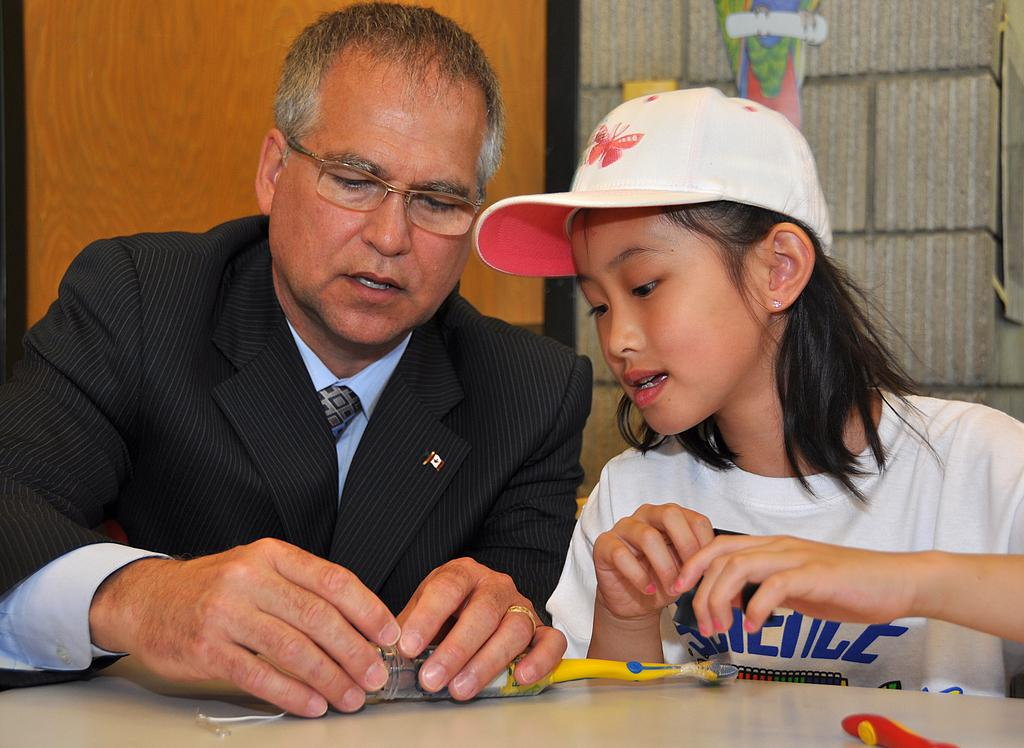What is the man in the image doing? The man is sitting in the image. What is the man holding in the image? The man is holding an object in the image. Where is the object placed in the image? The object is placed on a table in the image. What is the girl in the image wearing? The girl is wearing a cap in the image. On which side of the image is the girl sitting? The girl is sitting on the right side in the image. How many babies are visible in the image? There are no babies visible in the image. What type of pear is being used as a body pillow in the image? There is no pear being used as a body pillow in the image. 